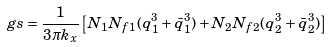<formula> <loc_0><loc_0><loc_500><loc_500>\ g s = \frac { 1 } { 3 \pi k _ { x } } \left [ N _ { 1 } N _ { f 1 } ( q _ { 1 } ^ { 3 } + \bar { q } _ { 1 } ^ { 3 } ) + N _ { 2 } N _ { f 2 } ( q _ { 2 } ^ { 3 } + \bar { q } _ { 2 } ^ { 3 } ) \right ]</formula> 